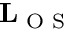<formula> <loc_0><loc_0><loc_500><loc_500>L _ { O S }</formula> 